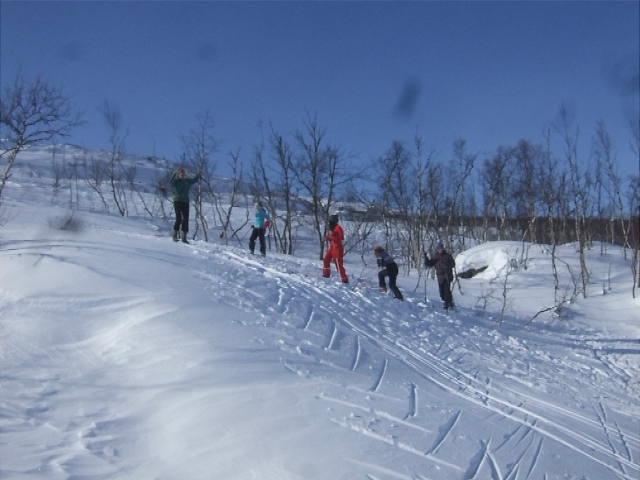Who is the man in red trying to reach? high 